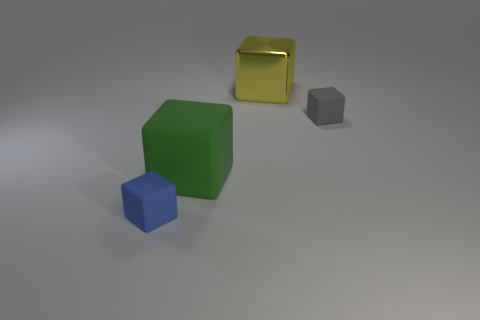Add 3 large cyan spheres. How many objects exist? 7 Add 1 matte things. How many matte things are left? 4 Add 4 gray rubber balls. How many gray rubber balls exist? 4 Subtract 0 purple cylinders. How many objects are left? 4 Subtract all large green cubes. Subtract all large yellow metal objects. How many objects are left? 2 